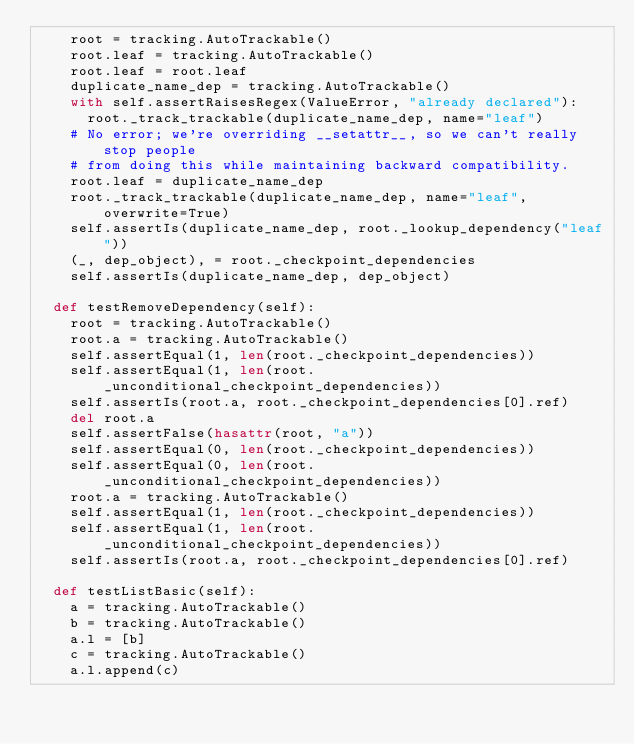<code> <loc_0><loc_0><loc_500><loc_500><_Python_>    root = tracking.AutoTrackable()
    root.leaf = tracking.AutoTrackable()
    root.leaf = root.leaf
    duplicate_name_dep = tracking.AutoTrackable()
    with self.assertRaisesRegex(ValueError, "already declared"):
      root._track_trackable(duplicate_name_dep, name="leaf")
    # No error; we're overriding __setattr__, so we can't really stop people
    # from doing this while maintaining backward compatibility.
    root.leaf = duplicate_name_dep
    root._track_trackable(duplicate_name_dep, name="leaf", overwrite=True)
    self.assertIs(duplicate_name_dep, root._lookup_dependency("leaf"))
    (_, dep_object), = root._checkpoint_dependencies
    self.assertIs(duplicate_name_dep, dep_object)

  def testRemoveDependency(self):
    root = tracking.AutoTrackable()
    root.a = tracking.AutoTrackable()
    self.assertEqual(1, len(root._checkpoint_dependencies))
    self.assertEqual(1, len(root._unconditional_checkpoint_dependencies))
    self.assertIs(root.a, root._checkpoint_dependencies[0].ref)
    del root.a
    self.assertFalse(hasattr(root, "a"))
    self.assertEqual(0, len(root._checkpoint_dependencies))
    self.assertEqual(0, len(root._unconditional_checkpoint_dependencies))
    root.a = tracking.AutoTrackable()
    self.assertEqual(1, len(root._checkpoint_dependencies))
    self.assertEqual(1, len(root._unconditional_checkpoint_dependencies))
    self.assertIs(root.a, root._checkpoint_dependencies[0].ref)

  def testListBasic(self):
    a = tracking.AutoTrackable()
    b = tracking.AutoTrackable()
    a.l = [b]
    c = tracking.AutoTrackable()
    a.l.append(c)</code> 